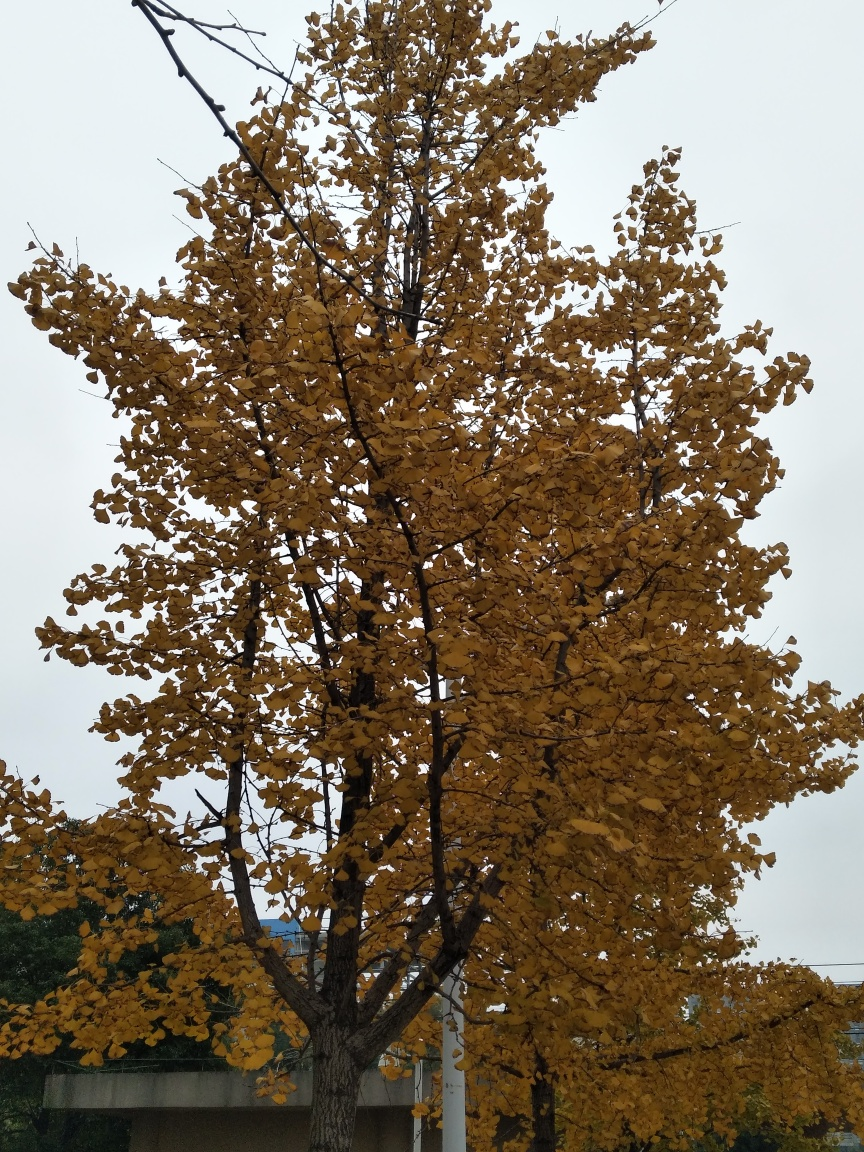What is the quality of texture details in the trees? The texture details in the trees are quite distinct and visually appealing. Individual leaves are discernible with variation in color tones ranging from deep amber to a lighter yellow. The interplay of light and shadow across the leaves creates a natural mosaic effect, and the multitude of leaves provides a sense of fullness and vitality typical of autumn foliage. 